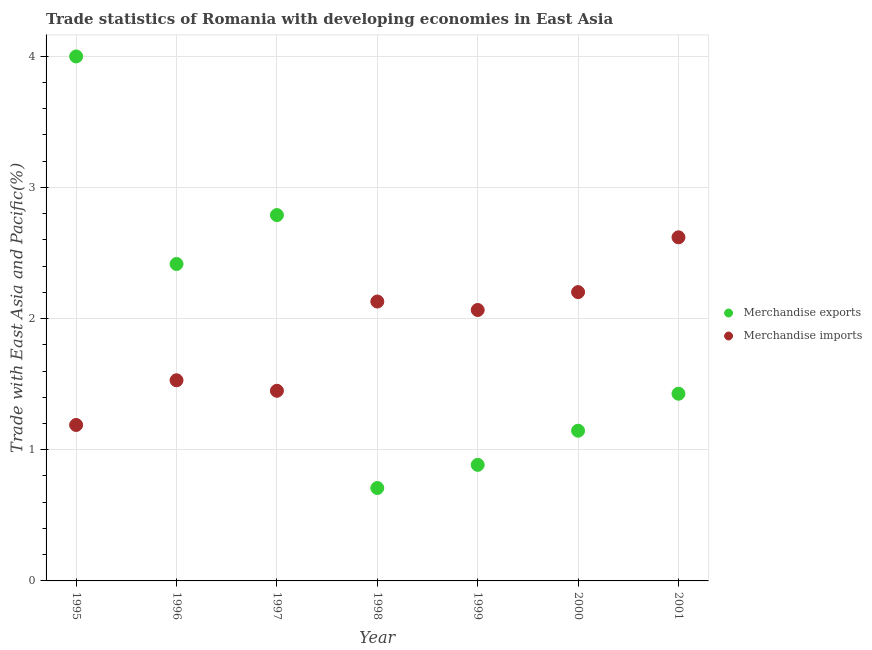How many different coloured dotlines are there?
Keep it short and to the point. 2. What is the merchandise exports in 1995?
Provide a short and direct response. 4. Across all years, what is the maximum merchandise imports?
Offer a terse response. 2.62. Across all years, what is the minimum merchandise imports?
Your response must be concise. 1.19. What is the total merchandise exports in the graph?
Offer a very short reply. 13.37. What is the difference between the merchandise imports in 1997 and that in 1999?
Provide a succinct answer. -0.62. What is the difference between the merchandise imports in 1996 and the merchandise exports in 1995?
Your answer should be compact. -2.47. What is the average merchandise exports per year?
Your response must be concise. 1.91. In the year 1996, what is the difference between the merchandise exports and merchandise imports?
Keep it short and to the point. 0.89. What is the ratio of the merchandise exports in 1996 to that in 1999?
Your response must be concise. 2.73. Is the merchandise exports in 1998 less than that in 2001?
Your response must be concise. Yes. What is the difference between the highest and the second highest merchandise exports?
Keep it short and to the point. 1.21. What is the difference between the highest and the lowest merchandise imports?
Give a very brief answer. 1.43. In how many years, is the merchandise imports greater than the average merchandise imports taken over all years?
Ensure brevity in your answer.  4. Is the sum of the merchandise exports in 1999 and 2001 greater than the maximum merchandise imports across all years?
Offer a very short reply. No. Does the merchandise exports monotonically increase over the years?
Make the answer very short. No. Is the merchandise imports strictly greater than the merchandise exports over the years?
Your answer should be compact. No. How many dotlines are there?
Offer a very short reply. 2. How many years are there in the graph?
Your answer should be very brief. 7. Does the graph contain grids?
Offer a very short reply. Yes. How many legend labels are there?
Your answer should be compact. 2. What is the title of the graph?
Your response must be concise. Trade statistics of Romania with developing economies in East Asia. What is the label or title of the Y-axis?
Provide a succinct answer. Trade with East Asia and Pacific(%). What is the Trade with East Asia and Pacific(%) in Merchandise exports in 1995?
Keep it short and to the point. 4. What is the Trade with East Asia and Pacific(%) in Merchandise imports in 1995?
Keep it short and to the point. 1.19. What is the Trade with East Asia and Pacific(%) of Merchandise exports in 1996?
Provide a succinct answer. 2.42. What is the Trade with East Asia and Pacific(%) in Merchandise imports in 1996?
Offer a terse response. 1.53. What is the Trade with East Asia and Pacific(%) in Merchandise exports in 1997?
Give a very brief answer. 2.79. What is the Trade with East Asia and Pacific(%) in Merchandise imports in 1997?
Ensure brevity in your answer.  1.45. What is the Trade with East Asia and Pacific(%) in Merchandise exports in 1998?
Keep it short and to the point. 0.71. What is the Trade with East Asia and Pacific(%) in Merchandise imports in 1998?
Ensure brevity in your answer.  2.13. What is the Trade with East Asia and Pacific(%) of Merchandise exports in 1999?
Keep it short and to the point. 0.88. What is the Trade with East Asia and Pacific(%) in Merchandise imports in 1999?
Offer a terse response. 2.07. What is the Trade with East Asia and Pacific(%) of Merchandise exports in 2000?
Your response must be concise. 1.15. What is the Trade with East Asia and Pacific(%) in Merchandise imports in 2000?
Offer a very short reply. 2.2. What is the Trade with East Asia and Pacific(%) of Merchandise exports in 2001?
Give a very brief answer. 1.43. What is the Trade with East Asia and Pacific(%) in Merchandise imports in 2001?
Your answer should be compact. 2.62. Across all years, what is the maximum Trade with East Asia and Pacific(%) in Merchandise exports?
Your answer should be compact. 4. Across all years, what is the maximum Trade with East Asia and Pacific(%) in Merchandise imports?
Provide a short and direct response. 2.62. Across all years, what is the minimum Trade with East Asia and Pacific(%) of Merchandise exports?
Your response must be concise. 0.71. Across all years, what is the minimum Trade with East Asia and Pacific(%) of Merchandise imports?
Make the answer very short. 1.19. What is the total Trade with East Asia and Pacific(%) of Merchandise exports in the graph?
Give a very brief answer. 13.37. What is the total Trade with East Asia and Pacific(%) of Merchandise imports in the graph?
Provide a succinct answer. 13.18. What is the difference between the Trade with East Asia and Pacific(%) in Merchandise exports in 1995 and that in 1996?
Provide a succinct answer. 1.58. What is the difference between the Trade with East Asia and Pacific(%) in Merchandise imports in 1995 and that in 1996?
Offer a very short reply. -0.34. What is the difference between the Trade with East Asia and Pacific(%) of Merchandise exports in 1995 and that in 1997?
Give a very brief answer. 1.21. What is the difference between the Trade with East Asia and Pacific(%) of Merchandise imports in 1995 and that in 1997?
Offer a very short reply. -0.26. What is the difference between the Trade with East Asia and Pacific(%) in Merchandise exports in 1995 and that in 1998?
Offer a very short reply. 3.29. What is the difference between the Trade with East Asia and Pacific(%) in Merchandise imports in 1995 and that in 1998?
Your answer should be compact. -0.94. What is the difference between the Trade with East Asia and Pacific(%) in Merchandise exports in 1995 and that in 1999?
Keep it short and to the point. 3.11. What is the difference between the Trade with East Asia and Pacific(%) of Merchandise imports in 1995 and that in 1999?
Offer a very short reply. -0.88. What is the difference between the Trade with East Asia and Pacific(%) in Merchandise exports in 1995 and that in 2000?
Give a very brief answer. 2.85. What is the difference between the Trade with East Asia and Pacific(%) of Merchandise imports in 1995 and that in 2000?
Your response must be concise. -1.01. What is the difference between the Trade with East Asia and Pacific(%) in Merchandise exports in 1995 and that in 2001?
Your response must be concise. 2.57. What is the difference between the Trade with East Asia and Pacific(%) of Merchandise imports in 1995 and that in 2001?
Keep it short and to the point. -1.43. What is the difference between the Trade with East Asia and Pacific(%) in Merchandise exports in 1996 and that in 1997?
Your answer should be compact. -0.37. What is the difference between the Trade with East Asia and Pacific(%) in Merchandise imports in 1996 and that in 1997?
Offer a very short reply. 0.08. What is the difference between the Trade with East Asia and Pacific(%) in Merchandise exports in 1996 and that in 1998?
Keep it short and to the point. 1.71. What is the difference between the Trade with East Asia and Pacific(%) in Merchandise imports in 1996 and that in 1998?
Your response must be concise. -0.6. What is the difference between the Trade with East Asia and Pacific(%) of Merchandise exports in 1996 and that in 1999?
Your answer should be compact. 1.53. What is the difference between the Trade with East Asia and Pacific(%) in Merchandise imports in 1996 and that in 1999?
Provide a succinct answer. -0.54. What is the difference between the Trade with East Asia and Pacific(%) of Merchandise exports in 1996 and that in 2000?
Your response must be concise. 1.27. What is the difference between the Trade with East Asia and Pacific(%) of Merchandise imports in 1996 and that in 2000?
Offer a very short reply. -0.67. What is the difference between the Trade with East Asia and Pacific(%) in Merchandise exports in 1996 and that in 2001?
Offer a very short reply. 0.99. What is the difference between the Trade with East Asia and Pacific(%) in Merchandise imports in 1996 and that in 2001?
Your response must be concise. -1.09. What is the difference between the Trade with East Asia and Pacific(%) of Merchandise exports in 1997 and that in 1998?
Give a very brief answer. 2.08. What is the difference between the Trade with East Asia and Pacific(%) of Merchandise imports in 1997 and that in 1998?
Make the answer very short. -0.68. What is the difference between the Trade with East Asia and Pacific(%) of Merchandise exports in 1997 and that in 1999?
Offer a terse response. 1.9. What is the difference between the Trade with East Asia and Pacific(%) in Merchandise imports in 1997 and that in 1999?
Your answer should be compact. -0.62. What is the difference between the Trade with East Asia and Pacific(%) of Merchandise exports in 1997 and that in 2000?
Provide a succinct answer. 1.64. What is the difference between the Trade with East Asia and Pacific(%) of Merchandise imports in 1997 and that in 2000?
Ensure brevity in your answer.  -0.75. What is the difference between the Trade with East Asia and Pacific(%) of Merchandise exports in 1997 and that in 2001?
Your answer should be very brief. 1.36. What is the difference between the Trade with East Asia and Pacific(%) in Merchandise imports in 1997 and that in 2001?
Give a very brief answer. -1.17. What is the difference between the Trade with East Asia and Pacific(%) in Merchandise exports in 1998 and that in 1999?
Your answer should be compact. -0.18. What is the difference between the Trade with East Asia and Pacific(%) of Merchandise imports in 1998 and that in 1999?
Keep it short and to the point. 0.06. What is the difference between the Trade with East Asia and Pacific(%) of Merchandise exports in 1998 and that in 2000?
Keep it short and to the point. -0.44. What is the difference between the Trade with East Asia and Pacific(%) in Merchandise imports in 1998 and that in 2000?
Your answer should be very brief. -0.07. What is the difference between the Trade with East Asia and Pacific(%) in Merchandise exports in 1998 and that in 2001?
Give a very brief answer. -0.72. What is the difference between the Trade with East Asia and Pacific(%) of Merchandise imports in 1998 and that in 2001?
Your response must be concise. -0.49. What is the difference between the Trade with East Asia and Pacific(%) of Merchandise exports in 1999 and that in 2000?
Provide a succinct answer. -0.26. What is the difference between the Trade with East Asia and Pacific(%) in Merchandise imports in 1999 and that in 2000?
Provide a succinct answer. -0.14. What is the difference between the Trade with East Asia and Pacific(%) in Merchandise exports in 1999 and that in 2001?
Provide a short and direct response. -0.54. What is the difference between the Trade with East Asia and Pacific(%) in Merchandise imports in 1999 and that in 2001?
Ensure brevity in your answer.  -0.55. What is the difference between the Trade with East Asia and Pacific(%) in Merchandise exports in 2000 and that in 2001?
Your answer should be very brief. -0.28. What is the difference between the Trade with East Asia and Pacific(%) in Merchandise imports in 2000 and that in 2001?
Keep it short and to the point. -0.42. What is the difference between the Trade with East Asia and Pacific(%) in Merchandise exports in 1995 and the Trade with East Asia and Pacific(%) in Merchandise imports in 1996?
Make the answer very short. 2.47. What is the difference between the Trade with East Asia and Pacific(%) of Merchandise exports in 1995 and the Trade with East Asia and Pacific(%) of Merchandise imports in 1997?
Ensure brevity in your answer.  2.55. What is the difference between the Trade with East Asia and Pacific(%) in Merchandise exports in 1995 and the Trade with East Asia and Pacific(%) in Merchandise imports in 1998?
Your response must be concise. 1.87. What is the difference between the Trade with East Asia and Pacific(%) of Merchandise exports in 1995 and the Trade with East Asia and Pacific(%) of Merchandise imports in 1999?
Give a very brief answer. 1.93. What is the difference between the Trade with East Asia and Pacific(%) of Merchandise exports in 1995 and the Trade with East Asia and Pacific(%) of Merchandise imports in 2000?
Make the answer very short. 1.8. What is the difference between the Trade with East Asia and Pacific(%) in Merchandise exports in 1995 and the Trade with East Asia and Pacific(%) in Merchandise imports in 2001?
Offer a terse response. 1.38. What is the difference between the Trade with East Asia and Pacific(%) in Merchandise exports in 1996 and the Trade with East Asia and Pacific(%) in Merchandise imports in 1997?
Provide a succinct answer. 0.97. What is the difference between the Trade with East Asia and Pacific(%) in Merchandise exports in 1996 and the Trade with East Asia and Pacific(%) in Merchandise imports in 1998?
Provide a short and direct response. 0.29. What is the difference between the Trade with East Asia and Pacific(%) of Merchandise exports in 1996 and the Trade with East Asia and Pacific(%) of Merchandise imports in 1999?
Make the answer very short. 0.35. What is the difference between the Trade with East Asia and Pacific(%) in Merchandise exports in 1996 and the Trade with East Asia and Pacific(%) in Merchandise imports in 2000?
Your answer should be compact. 0.21. What is the difference between the Trade with East Asia and Pacific(%) in Merchandise exports in 1996 and the Trade with East Asia and Pacific(%) in Merchandise imports in 2001?
Offer a very short reply. -0.2. What is the difference between the Trade with East Asia and Pacific(%) of Merchandise exports in 1997 and the Trade with East Asia and Pacific(%) of Merchandise imports in 1998?
Make the answer very short. 0.66. What is the difference between the Trade with East Asia and Pacific(%) of Merchandise exports in 1997 and the Trade with East Asia and Pacific(%) of Merchandise imports in 1999?
Offer a very short reply. 0.72. What is the difference between the Trade with East Asia and Pacific(%) of Merchandise exports in 1997 and the Trade with East Asia and Pacific(%) of Merchandise imports in 2000?
Keep it short and to the point. 0.59. What is the difference between the Trade with East Asia and Pacific(%) in Merchandise exports in 1997 and the Trade with East Asia and Pacific(%) in Merchandise imports in 2001?
Ensure brevity in your answer.  0.17. What is the difference between the Trade with East Asia and Pacific(%) of Merchandise exports in 1998 and the Trade with East Asia and Pacific(%) of Merchandise imports in 1999?
Offer a terse response. -1.36. What is the difference between the Trade with East Asia and Pacific(%) of Merchandise exports in 1998 and the Trade with East Asia and Pacific(%) of Merchandise imports in 2000?
Provide a succinct answer. -1.49. What is the difference between the Trade with East Asia and Pacific(%) of Merchandise exports in 1998 and the Trade with East Asia and Pacific(%) of Merchandise imports in 2001?
Your response must be concise. -1.91. What is the difference between the Trade with East Asia and Pacific(%) in Merchandise exports in 1999 and the Trade with East Asia and Pacific(%) in Merchandise imports in 2000?
Offer a terse response. -1.32. What is the difference between the Trade with East Asia and Pacific(%) of Merchandise exports in 1999 and the Trade with East Asia and Pacific(%) of Merchandise imports in 2001?
Your response must be concise. -1.73. What is the difference between the Trade with East Asia and Pacific(%) in Merchandise exports in 2000 and the Trade with East Asia and Pacific(%) in Merchandise imports in 2001?
Your answer should be very brief. -1.47. What is the average Trade with East Asia and Pacific(%) in Merchandise exports per year?
Keep it short and to the point. 1.91. What is the average Trade with East Asia and Pacific(%) of Merchandise imports per year?
Keep it short and to the point. 1.88. In the year 1995, what is the difference between the Trade with East Asia and Pacific(%) of Merchandise exports and Trade with East Asia and Pacific(%) of Merchandise imports?
Provide a succinct answer. 2.81. In the year 1996, what is the difference between the Trade with East Asia and Pacific(%) in Merchandise exports and Trade with East Asia and Pacific(%) in Merchandise imports?
Your response must be concise. 0.89. In the year 1997, what is the difference between the Trade with East Asia and Pacific(%) in Merchandise exports and Trade with East Asia and Pacific(%) in Merchandise imports?
Your response must be concise. 1.34. In the year 1998, what is the difference between the Trade with East Asia and Pacific(%) of Merchandise exports and Trade with East Asia and Pacific(%) of Merchandise imports?
Offer a very short reply. -1.42. In the year 1999, what is the difference between the Trade with East Asia and Pacific(%) in Merchandise exports and Trade with East Asia and Pacific(%) in Merchandise imports?
Make the answer very short. -1.18. In the year 2000, what is the difference between the Trade with East Asia and Pacific(%) in Merchandise exports and Trade with East Asia and Pacific(%) in Merchandise imports?
Make the answer very short. -1.06. In the year 2001, what is the difference between the Trade with East Asia and Pacific(%) in Merchandise exports and Trade with East Asia and Pacific(%) in Merchandise imports?
Make the answer very short. -1.19. What is the ratio of the Trade with East Asia and Pacific(%) in Merchandise exports in 1995 to that in 1996?
Provide a succinct answer. 1.65. What is the ratio of the Trade with East Asia and Pacific(%) of Merchandise imports in 1995 to that in 1996?
Provide a succinct answer. 0.78. What is the ratio of the Trade with East Asia and Pacific(%) of Merchandise exports in 1995 to that in 1997?
Your answer should be very brief. 1.43. What is the ratio of the Trade with East Asia and Pacific(%) in Merchandise imports in 1995 to that in 1997?
Offer a very short reply. 0.82. What is the ratio of the Trade with East Asia and Pacific(%) in Merchandise exports in 1995 to that in 1998?
Your answer should be very brief. 5.64. What is the ratio of the Trade with East Asia and Pacific(%) of Merchandise imports in 1995 to that in 1998?
Offer a terse response. 0.56. What is the ratio of the Trade with East Asia and Pacific(%) in Merchandise exports in 1995 to that in 1999?
Offer a very short reply. 4.52. What is the ratio of the Trade with East Asia and Pacific(%) of Merchandise imports in 1995 to that in 1999?
Make the answer very short. 0.58. What is the ratio of the Trade with East Asia and Pacific(%) of Merchandise exports in 1995 to that in 2000?
Provide a short and direct response. 3.49. What is the ratio of the Trade with East Asia and Pacific(%) of Merchandise imports in 1995 to that in 2000?
Keep it short and to the point. 0.54. What is the ratio of the Trade with East Asia and Pacific(%) of Merchandise exports in 1995 to that in 2001?
Offer a terse response. 2.8. What is the ratio of the Trade with East Asia and Pacific(%) of Merchandise imports in 1995 to that in 2001?
Offer a very short reply. 0.45. What is the ratio of the Trade with East Asia and Pacific(%) in Merchandise exports in 1996 to that in 1997?
Offer a terse response. 0.87. What is the ratio of the Trade with East Asia and Pacific(%) of Merchandise imports in 1996 to that in 1997?
Provide a short and direct response. 1.06. What is the ratio of the Trade with East Asia and Pacific(%) of Merchandise exports in 1996 to that in 1998?
Offer a terse response. 3.41. What is the ratio of the Trade with East Asia and Pacific(%) of Merchandise imports in 1996 to that in 1998?
Make the answer very short. 0.72. What is the ratio of the Trade with East Asia and Pacific(%) in Merchandise exports in 1996 to that in 1999?
Keep it short and to the point. 2.73. What is the ratio of the Trade with East Asia and Pacific(%) in Merchandise imports in 1996 to that in 1999?
Give a very brief answer. 0.74. What is the ratio of the Trade with East Asia and Pacific(%) of Merchandise exports in 1996 to that in 2000?
Make the answer very short. 2.11. What is the ratio of the Trade with East Asia and Pacific(%) in Merchandise imports in 1996 to that in 2000?
Your answer should be very brief. 0.69. What is the ratio of the Trade with East Asia and Pacific(%) in Merchandise exports in 1996 to that in 2001?
Your answer should be very brief. 1.69. What is the ratio of the Trade with East Asia and Pacific(%) of Merchandise imports in 1996 to that in 2001?
Give a very brief answer. 0.58. What is the ratio of the Trade with East Asia and Pacific(%) of Merchandise exports in 1997 to that in 1998?
Your answer should be very brief. 3.94. What is the ratio of the Trade with East Asia and Pacific(%) of Merchandise imports in 1997 to that in 1998?
Ensure brevity in your answer.  0.68. What is the ratio of the Trade with East Asia and Pacific(%) of Merchandise exports in 1997 to that in 1999?
Make the answer very short. 3.15. What is the ratio of the Trade with East Asia and Pacific(%) of Merchandise imports in 1997 to that in 1999?
Offer a terse response. 0.7. What is the ratio of the Trade with East Asia and Pacific(%) of Merchandise exports in 1997 to that in 2000?
Offer a very short reply. 2.44. What is the ratio of the Trade with East Asia and Pacific(%) in Merchandise imports in 1997 to that in 2000?
Ensure brevity in your answer.  0.66. What is the ratio of the Trade with East Asia and Pacific(%) in Merchandise exports in 1997 to that in 2001?
Offer a very short reply. 1.95. What is the ratio of the Trade with East Asia and Pacific(%) in Merchandise imports in 1997 to that in 2001?
Ensure brevity in your answer.  0.55. What is the ratio of the Trade with East Asia and Pacific(%) in Merchandise exports in 1998 to that in 1999?
Give a very brief answer. 0.8. What is the ratio of the Trade with East Asia and Pacific(%) in Merchandise imports in 1998 to that in 1999?
Your answer should be compact. 1.03. What is the ratio of the Trade with East Asia and Pacific(%) of Merchandise exports in 1998 to that in 2000?
Your answer should be compact. 0.62. What is the ratio of the Trade with East Asia and Pacific(%) in Merchandise imports in 1998 to that in 2000?
Provide a short and direct response. 0.97. What is the ratio of the Trade with East Asia and Pacific(%) in Merchandise exports in 1998 to that in 2001?
Your answer should be compact. 0.5. What is the ratio of the Trade with East Asia and Pacific(%) of Merchandise imports in 1998 to that in 2001?
Your answer should be compact. 0.81. What is the ratio of the Trade with East Asia and Pacific(%) of Merchandise exports in 1999 to that in 2000?
Ensure brevity in your answer.  0.77. What is the ratio of the Trade with East Asia and Pacific(%) of Merchandise imports in 1999 to that in 2000?
Your answer should be compact. 0.94. What is the ratio of the Trade with East Asia and Pacific(%) of Merchandise exports in 1999 to that in 2001?
Keep it short and to the point. 0.62. What is the ratio of the Trade with East Asia and Pacific(%) in Merchandise imports in 1999 to that in 2001?
Your answer should be compact. 0.79. What is the ratio of the Trade with East Asia and Pacific(%) in Merchandise exports in 2000 to that in 2001?
Offer a terse response. 0.8. What is the ratio of the Trade with East Asia and Pacific(%) of Merchandise imports in 2000 to that in 2001?
Your response must be concise. 0.84. What is the difference between the highest and the second highest Trade with East Asia and Pacific(%) in Merchandise exports?
Your response must be concise. 1.21. What is the difference between the highest and the second highest Trade with East Asia and Pacific(%) of Merchandise imports?
Offer a very short reply. 0.42. What is the difference between the highest and the lowest Trade with East Asia and Pacific(%) in Merchandise exports?
Ensure brevity in your answer.  3.29. What is the difference between the highest and the lowest Trade with East Asia and Pacific(%) of Merchandise imports?
Offer a terse response. 1.43. 